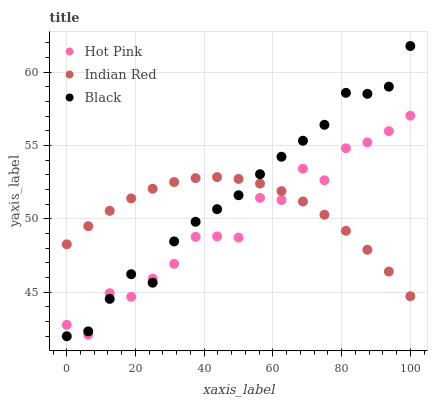Does Hot Pink have the minimum area under the curve?
Answer yes or no. Yes. Does Black have the maximum area under the curve?
Answer yes or no. Yes. Does Indian Red have the minimum area under the curve?
Answer yes or no. No. Does Indian Red have the maximum area under the curve?
Answer yes or no. No. Is Indian Red the smoothest?
Answer yes or no. Yes. Is Hot Pink the roughest?
Answer yes or no. Yes. Is Black the smoothest?
Answer yes or no. No. Is Black the roughest?
Answer yes or no. No. Does Black have the lowest value?
Answer yes or no. Yes. Does Indian Red have the lowest value?
Answer yes or no. No. Does Black have the highest value?
Answer yes or no. Yes. Does Indian Red have the highest value?
Answer yes or no. No. Does Black intersect Hot Pink?
Answer yes or no. Yes. Is Black less than Hot Pink?
Answer yes or no. No. Is Black greater than Hot Pink?
Answer yes or no. No. 